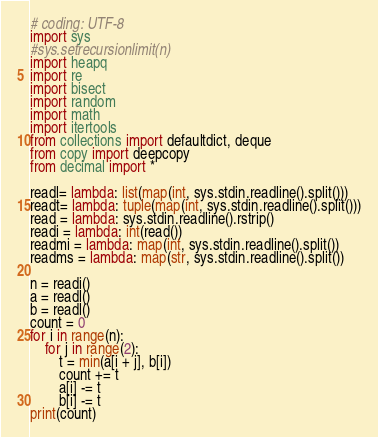Convert code to text. <code><loc_0><loc_0><loc_500><loc_500><_Python_># coding: UTF-8
import sys
#sys.setrecursionlimit(n)
import heapq
import re
import bisect
import random
import math
import itertools
from collections import defaultdict, deque
from copy import deepcopy
from decimal import *

readl= lambda: list(map(int, sys.stdin.readline().split()))
readt= lambda: tuple(map(int, sys.stdin.readline().split()))
read = lambda: sys.stdin.readline().rstrip()
readi = lambda: int(read())
readmi = lambda: map(int, sys.stdin.readline().split())
readms = lambda: map(str, sys.stdin.readline().split())

n = readi()
a = readl()
b = readl()
count = 0
for i in range(n):
    for j in range(2):
        t = min(a[i + j], b[i])
        count += t
        a[i] -= t
        b[i] -= t
print(count)</code> 